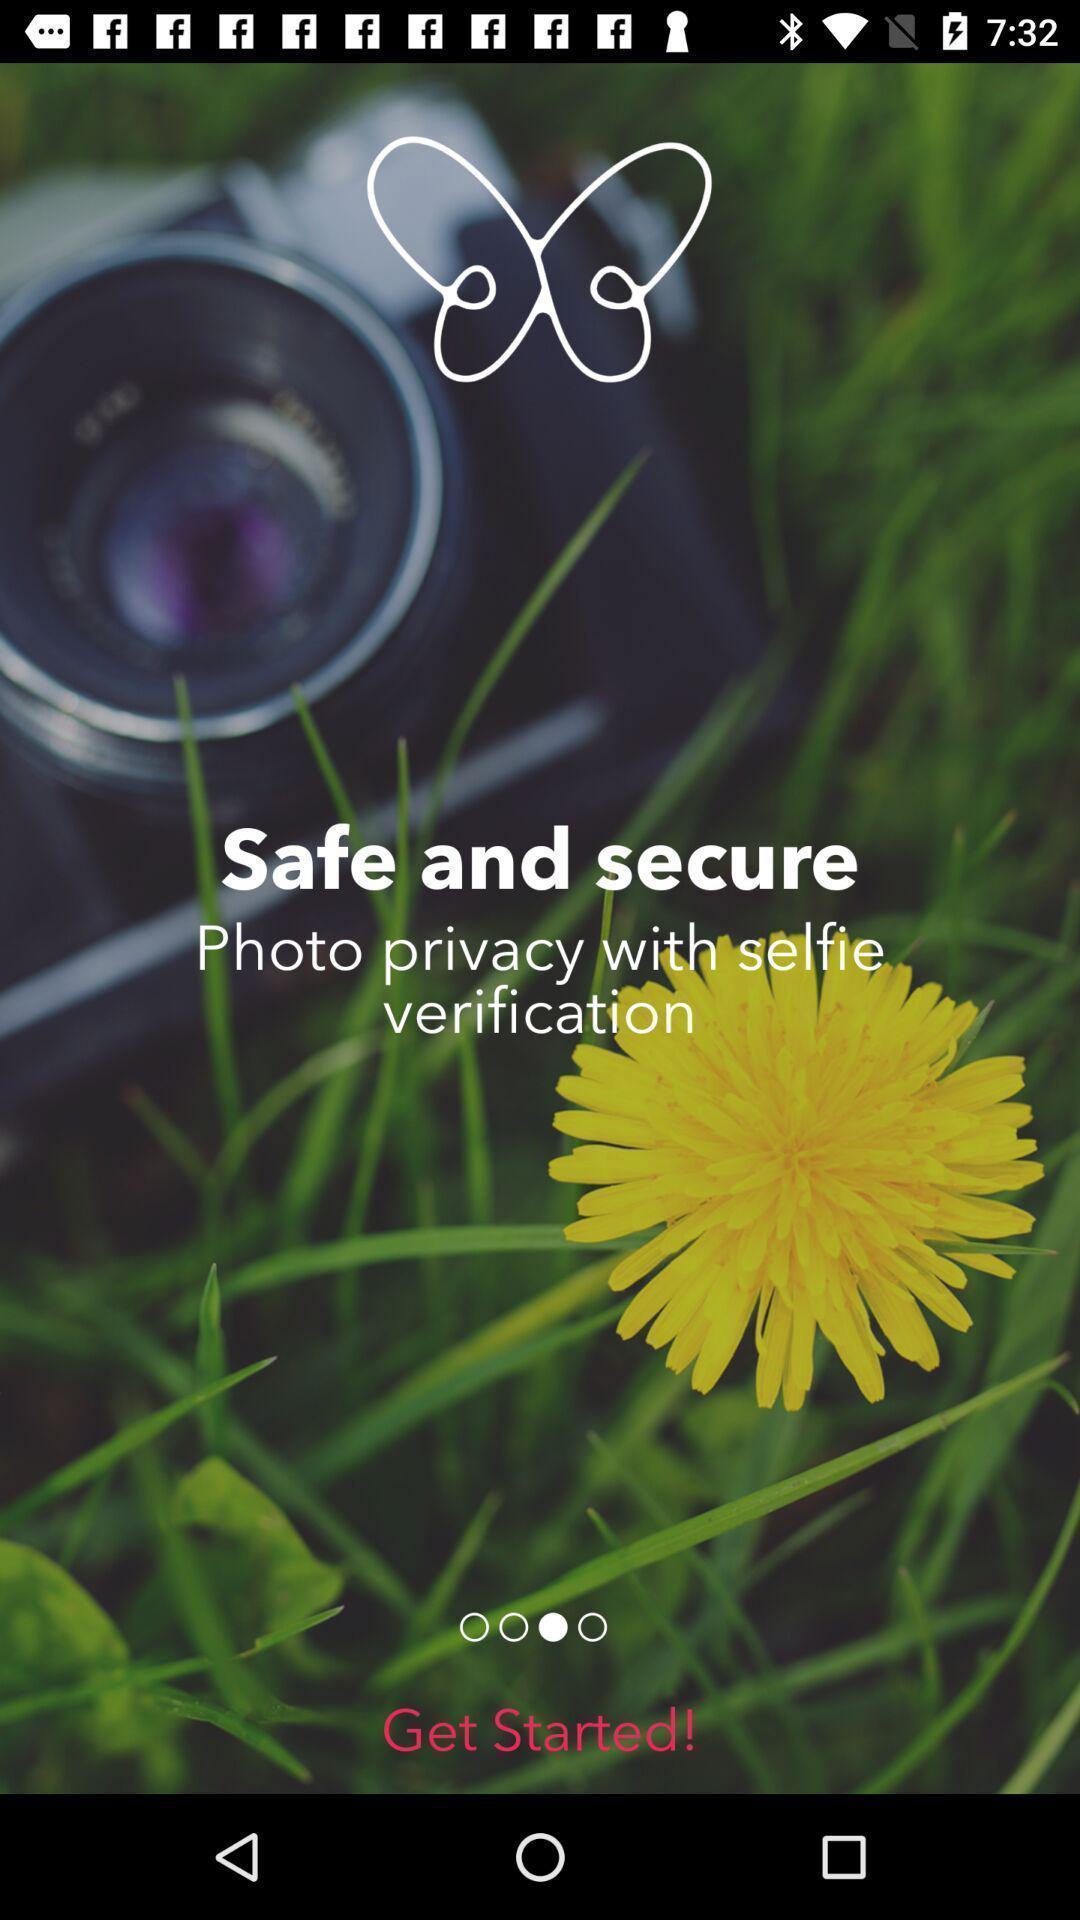What can you discern from this picture? Photo verification page. 